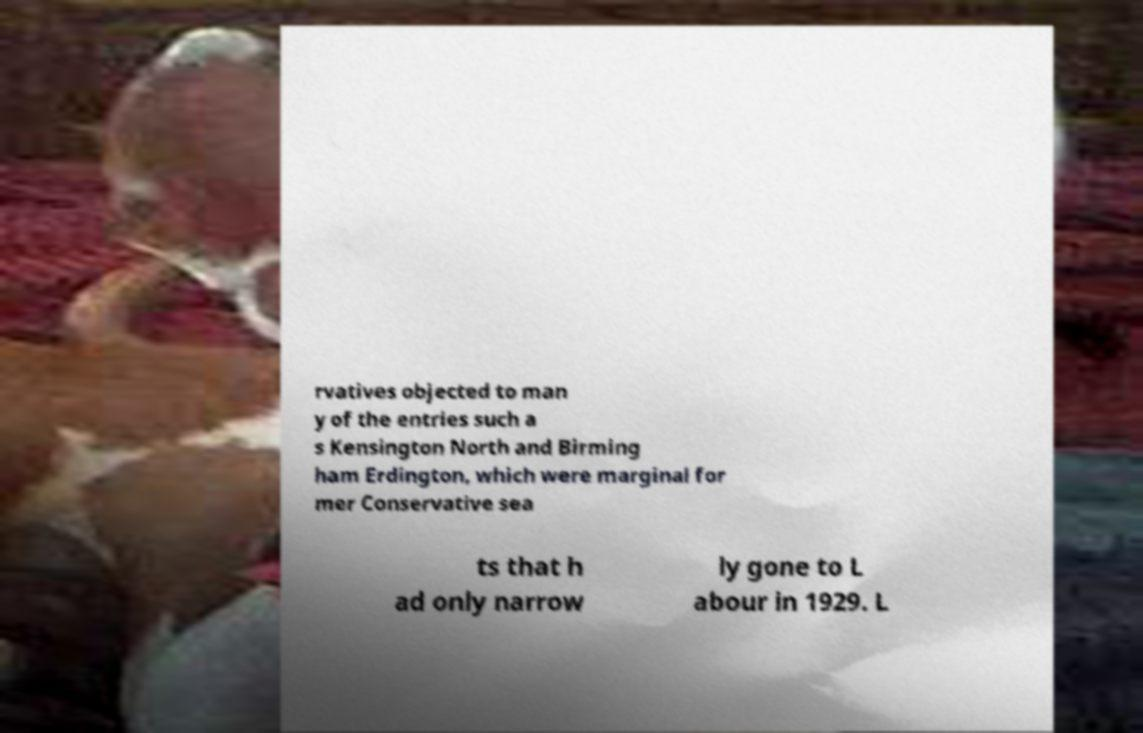Please identify and transcribe the text found in this image. rvatives objected to man y of the entries such a s Kensington North and Birming ham Erdington, which were marginal for mer Conservative sea ts that h ad only narrow ly gone to L abour in 1929. L 